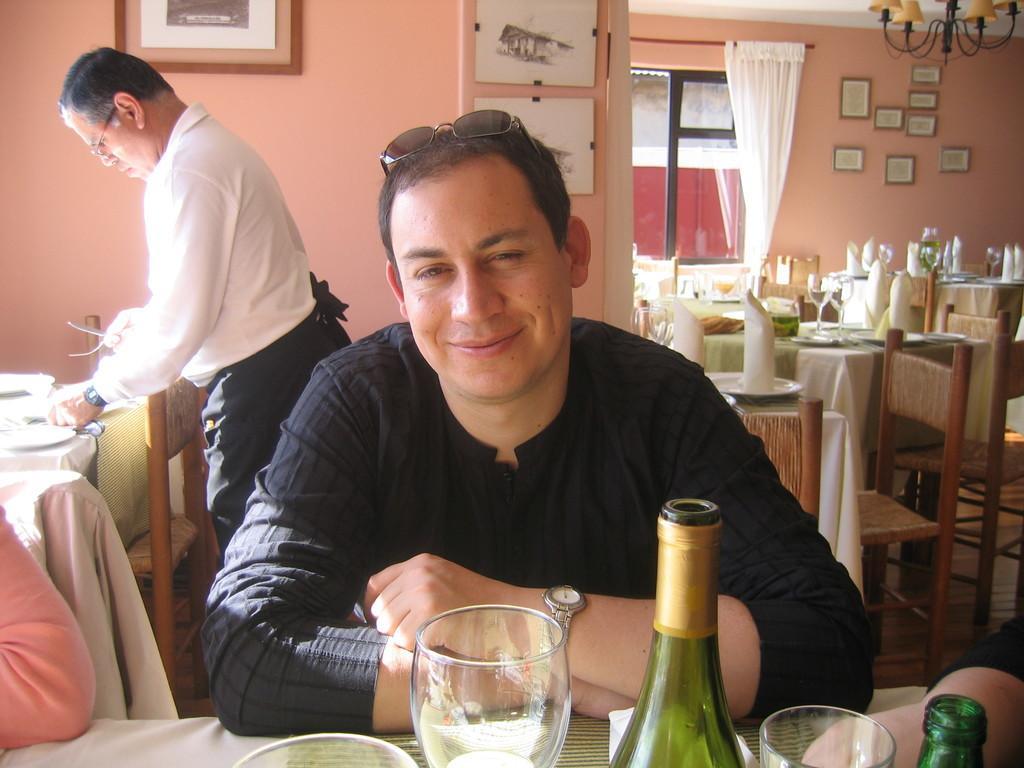Could you give a brief overview of what you see in this image? In this image I can see two men where one is standing and one is sitting. I can see one is wearing white colour shirt and he is wearing black colour t shirt. I can also see few chairs, tables and on these tables I can see number of glasses, bottles and napkins. In the background I can see number of frames on these walls, a window and a white colour curtain. 